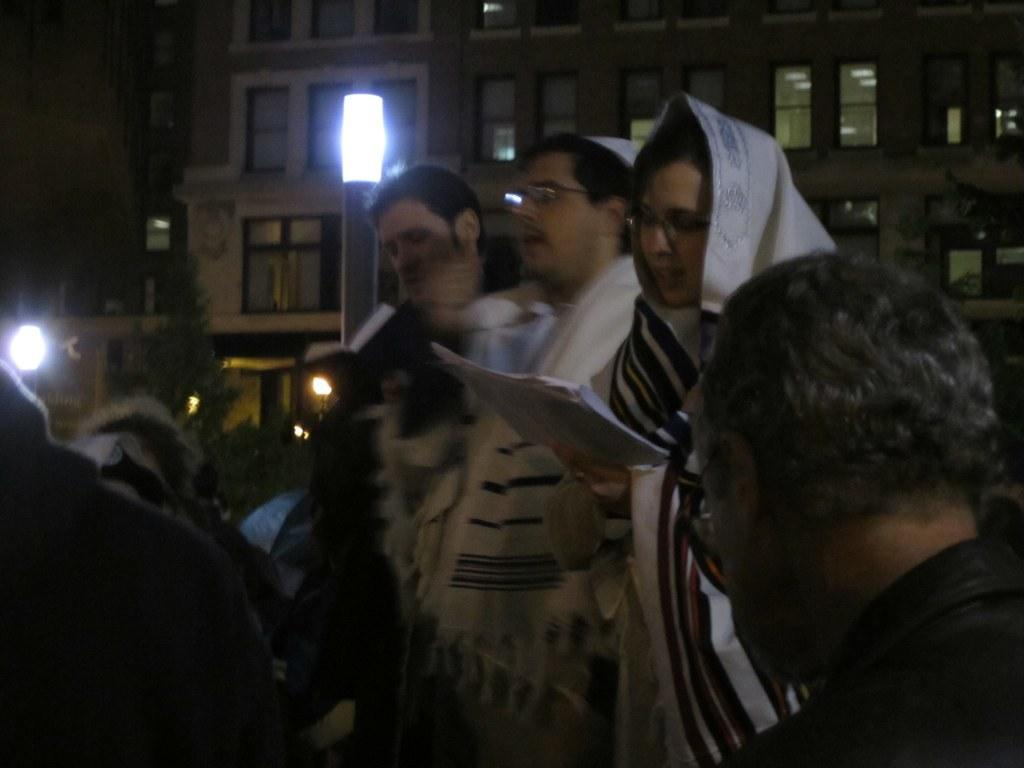What is the main subject of the image? The main subject of the image is people in the center. What can be seen in the background of the image? There is a building in the background of the image. What feature of the building is mentioned? The building has windows. Where is the light located in the image? The light is on the left side of the image. How many matches can be seen in the image? There are no matches present in the image. What type of worm is crawling on the building in the image? There are no worms present in the image; it only features people, a building, and a light. 